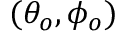Convert formula to latex. <formula><loc_0><loc_0><loc_500><loc_500>( \theta _ { o } , \phi _ { o } )</formula> 